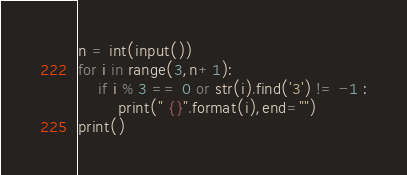<code> <loc_0><loc_0><loc_500><loc_500><_Python_>n = int(input())
for i in range(3,n+1):
    if i % 3 == 0 or str(i).find('3') != -1 :
        print(" {}".format(i),end="")
print()
</code> 